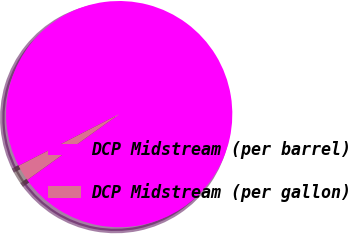Convert chart to OTSL. <chart><loc_0><loc_0><loc_500><loc_500><pie_chart><fcel>DCP Midstream (per barrel)<fcel>DCP Midstream (per gallon)<nl><fcel>97.66%<fcel>2.34%<nl></chart> 